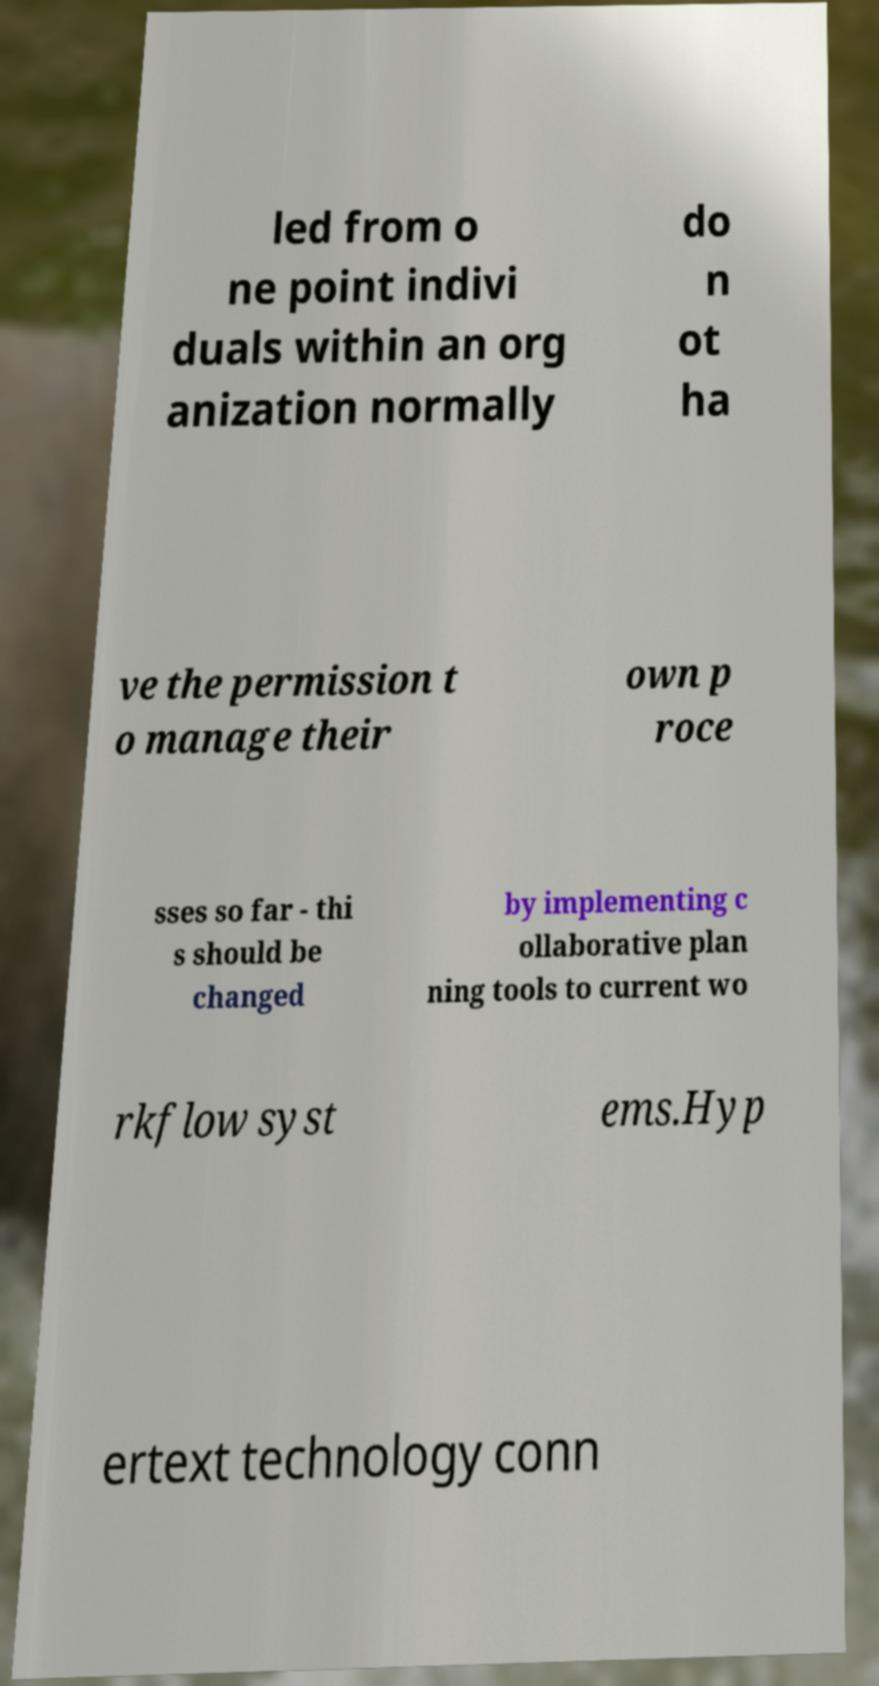Could you assist in decoding the text presented in this image and type it out clearly? led from o ne point indivi duals within an org anization normally do n ot ha ve the permission t o manage their own p roce sses so far - thi s should be changed by implementing c ollaborative plan ning tools to current wo rkflow syst ems.Hyp ertext technology conn 